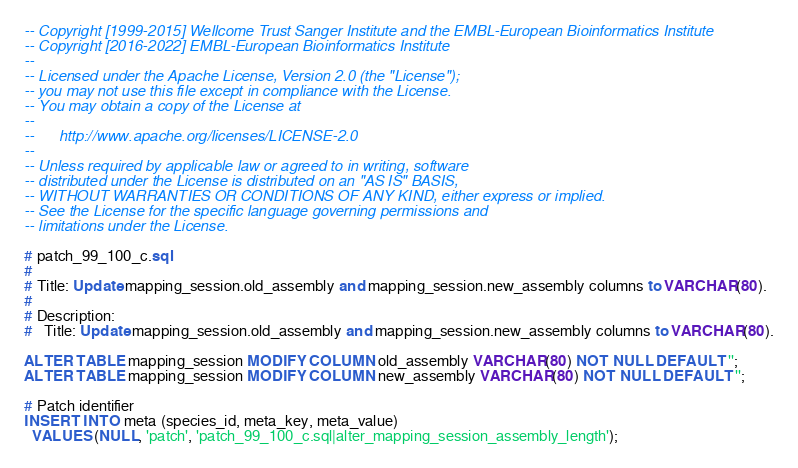Convert code to text. <code><loc_0><loc_0><loc_500><loc_500><_SQL_>-- Copyright [1999-2015] Wellcome Trust Sanger Institute and the EMBL-European Bioinformatics Institute
-- Copyright [2016-2022] EMBL-European Bioinformatics Institute
--
-- Licensed under the Apache License, Version 2.0 (the "License");
-- you may not use this file except in compliance with the License.
-- You may obtain a copy of the License at
--
--      http://www.apache.org/licenses/LICENSE-2.0
--
-- Unless required by applicable law or agreed to in writing, software
-- distributed under the License is distributed on an "AS IS" BASIS,
-- WITHOUT WARRANTIES OR CONDITIONS OF ANY KIND, either express or implied.
-- See the License for the specific language governing permissions and
-- limitations under the License.

# patch_99_100_c.sql
#
# Title: Update mapping_session.old_assembly and mapping_session.new_assembly columns to VARCHAR(80).
#
# Description:
#   Title: Update mapping_session.old_assembly and mapping_session.new_assembly columns to VARCHAR(80).

ALTER TABLE mapping_session MODIFY COLUMN old_assembly VARCHAR(80) NOT NULL DEFAULT '';
ALTER TABLE mapping_session MODIFY COLUMN new_assembly VARCHAR(80) NOT NULL DEFAULT '';

# Patch identifier
INSERT INTO meta (species_id, meta_key, meta_value)
  VALUES (NULL, 'patch', 'patch_99_100_c.sql|alter_mapping_session_assembly_length');
</code> 